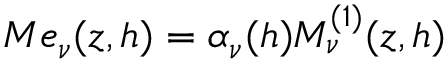<formula> <loc_0><loc_0><loc_500><loc_500>M e _ { \nu } ( z , h ) = \alpha _ { \nu } ( h ) M _ { \nu } ^ { ( 1 ) } ( z , h )</formula> 